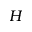<formula> <loc_0><loc_0><loc_500><loc_500>H</formula> 